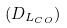<formula> <loc_0><loc_0><loc_500><loc_500>( D _ { L _ { C O } } )</formula> 